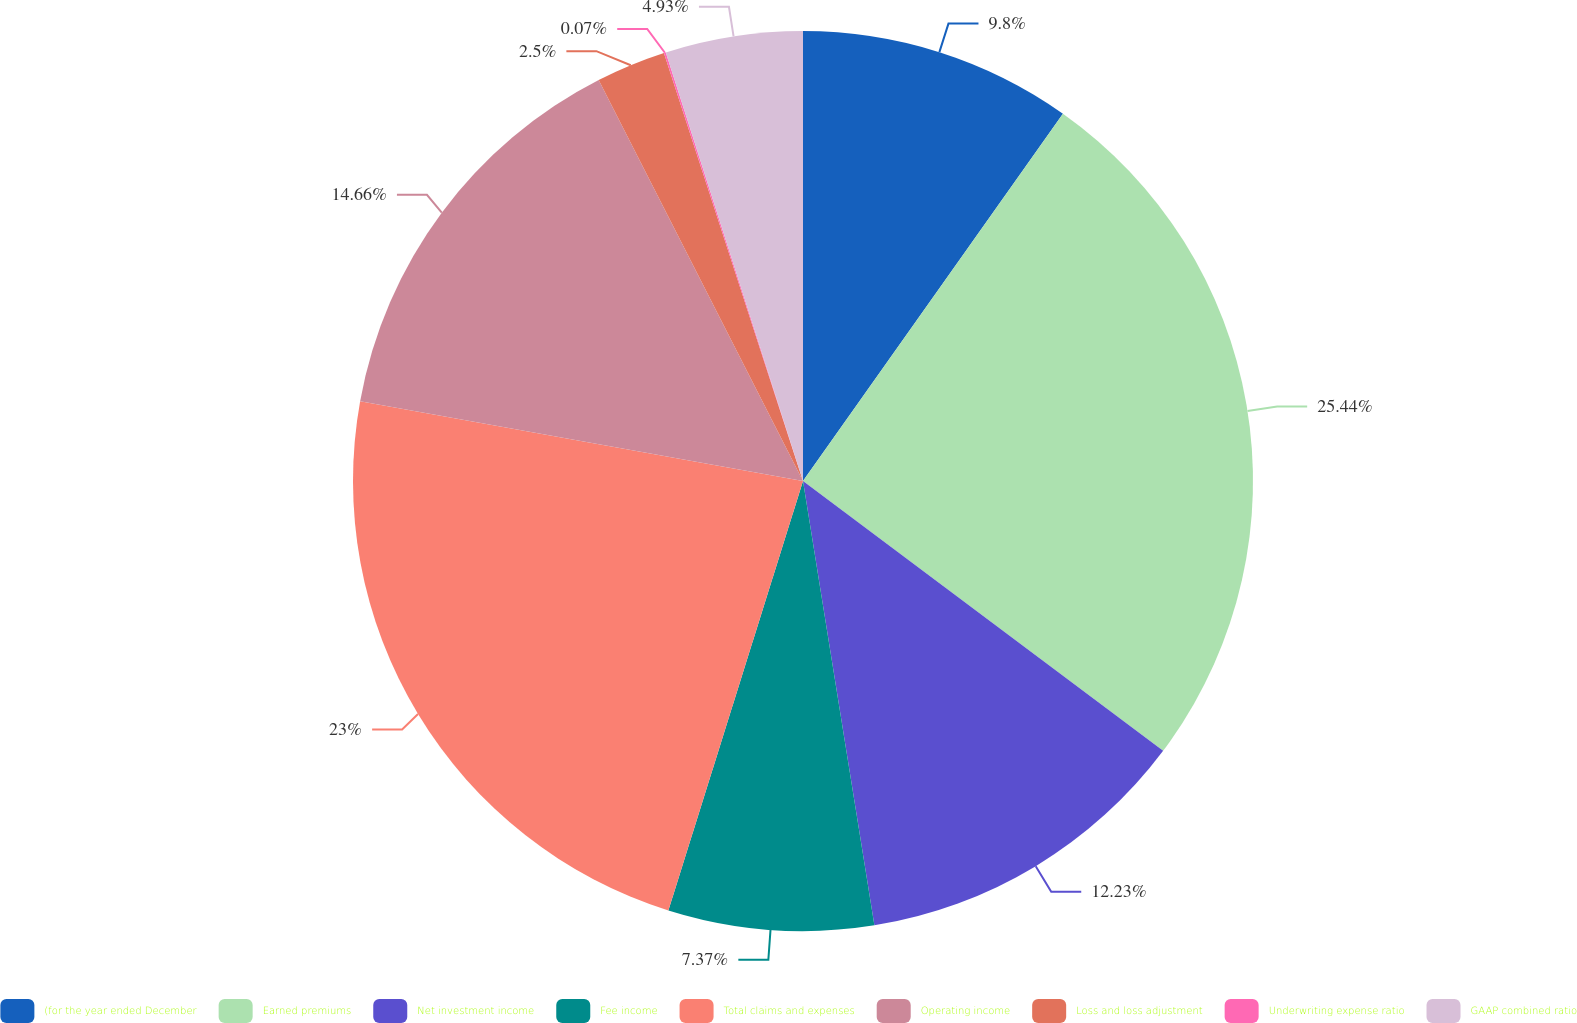Convert chart. <chart><loc_0><loc_0><loc_500><loc_500><pie_chart><fcel>(for the year ended December<fcel>Earned premiums<fcel>Net investment income<fcel>Fee income<fcel>Total claims and expenses<fcel>Operating income<fcel>Loss and loss adjustment<fcel>Underwriting expense ratio<fcel>GAAP combined ratio<nl><fcel>9.8%<fcel>25.43%<fcel>12.23%<fcel>7.37%<fcel>23.0%<fcel>14.66%<fcel>2.5%<fcel>0.07%<fcel>4.93%<nl></chart> 